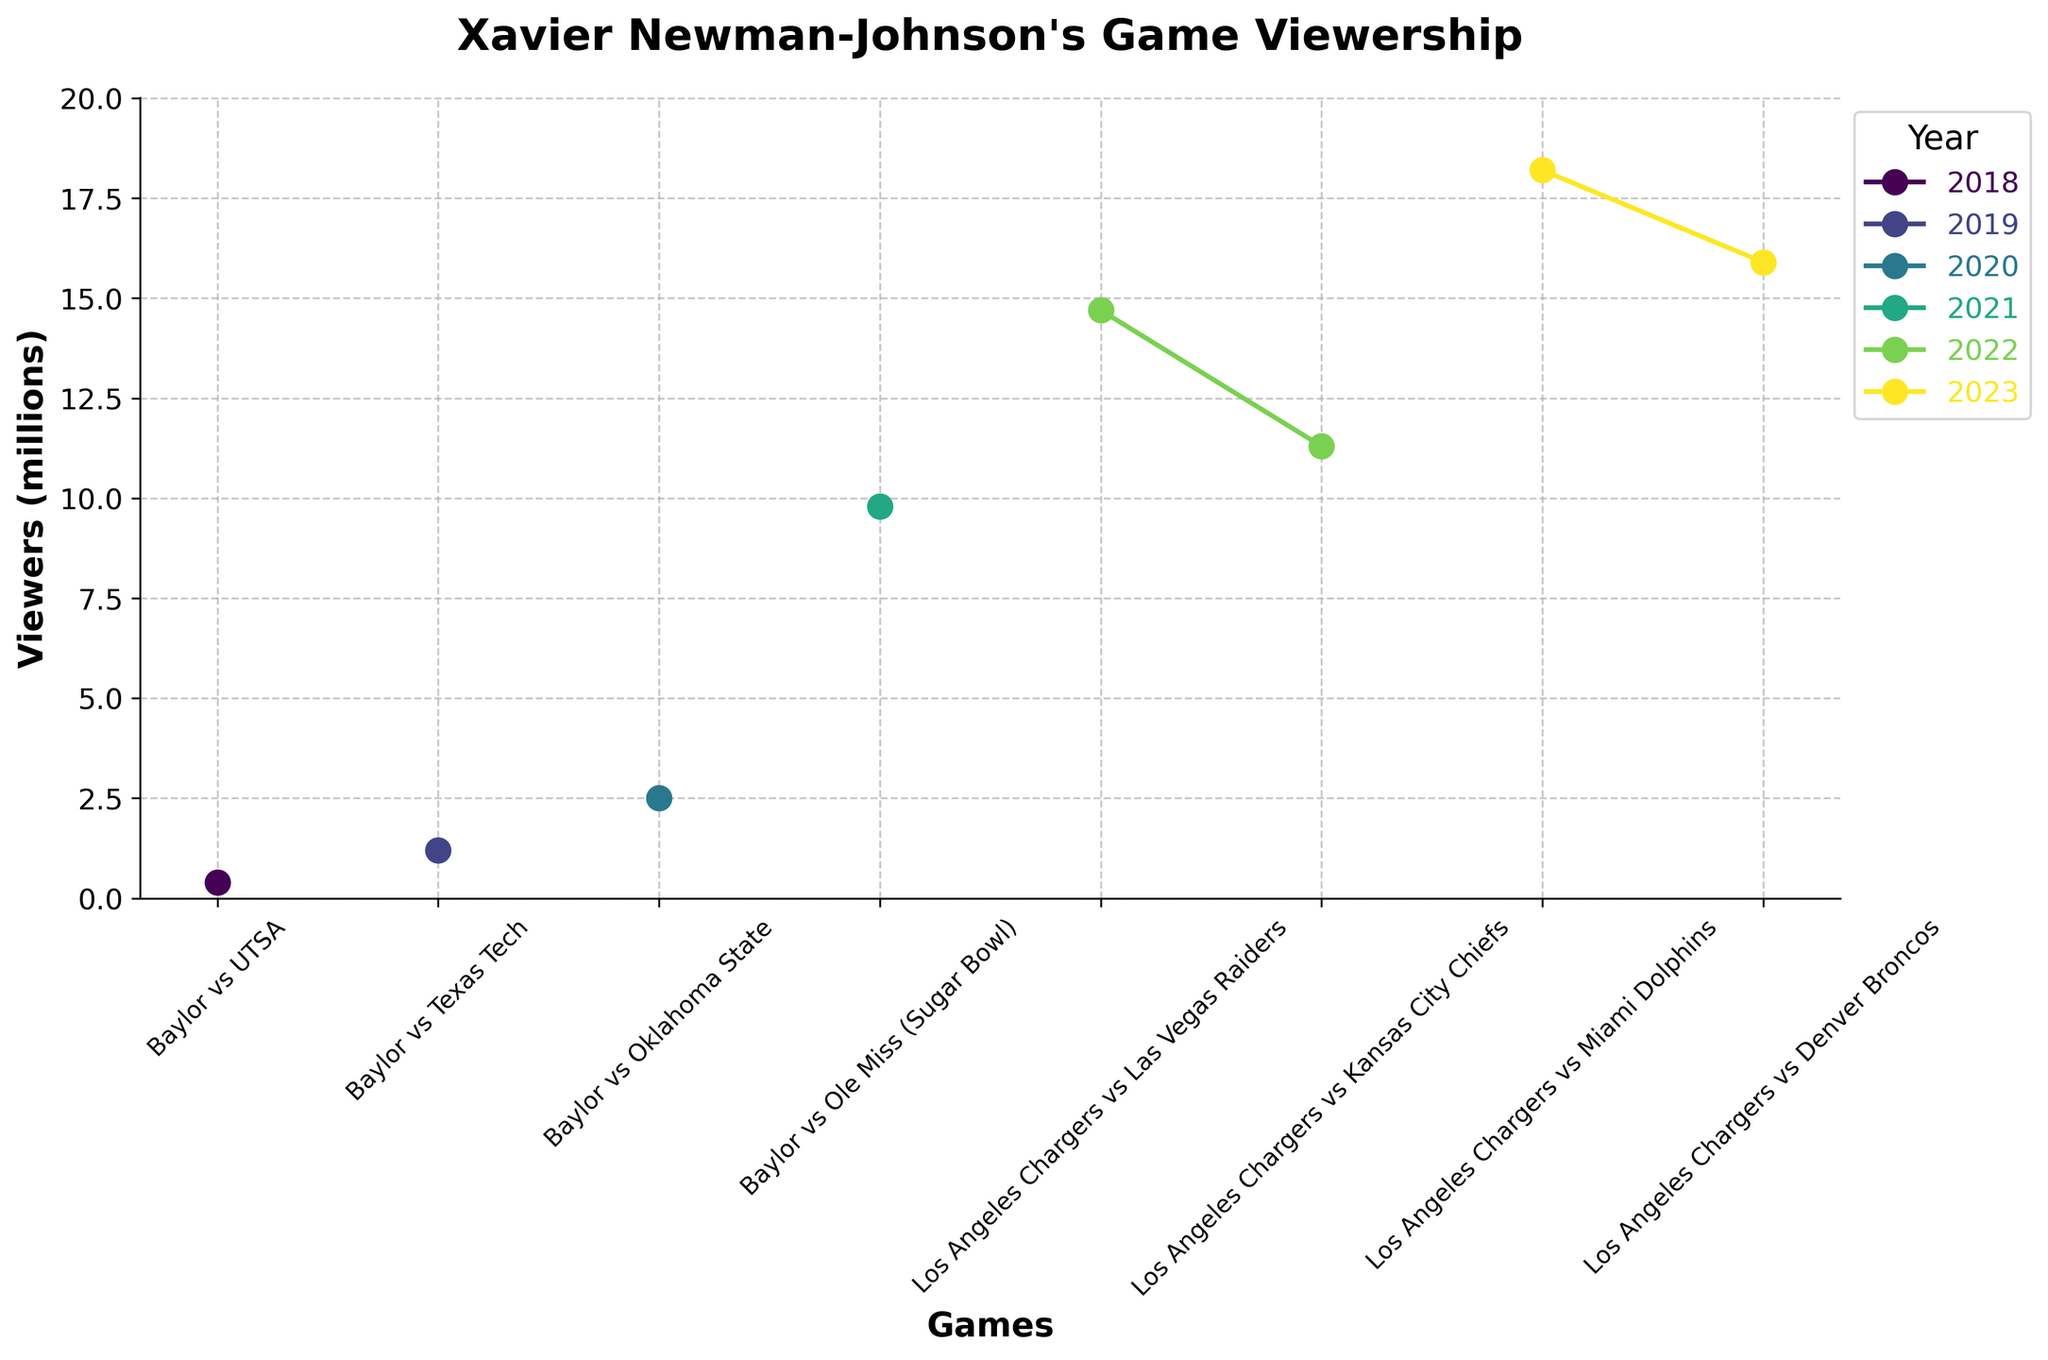What's the average number of viewers for the games in 2022? In 2022, the viewers for the games are 14.7 million and 11.3 million. Sum these two numbers to get 26 million, and then divide by 2 to get the average. 26 / 2 = 13
Answer: 13 Which game had the highest viewership and in which year did it occur? The highest bar in the chart represents the Los Angeles Chargers vs Miami Dolphins game with 18.2 million viewers in 2023.
Answer: Los Angeles Chargers vs Miami Dolphins, 2023 How did viewership change from the 2021 Sugar Bowl to the Los Angeles Chargers vs Raiders game in 2022? The viewership in the 2021 Sugar Bowl was 9.8 million. For the Los Angeles Chargers vs Raiders game in 2022, it was 14.7 million. Subtract 9.8 from 14.7 to see the increase. 14.7 - 9.8 = 4.9 million increase.
Answer: 4.9 million increase What's the total viewership for games in 2023? The viewers for the 2023 games are 18.2 million and 15.9 million. Sum these two numbers to get the total. 18.2 + 15.9 = 34.1 million.
Answer: 34.1 million Which game had the lowest viewership, and what was the network broadcasting it? The lowest bar in the chart represents the Baylor vs UTSA game with 0.4 million viewers, broadcasted on Fox Sports Southwest.
Answer: Baylor vs UTSA, Fox Sports Southwest Is there a trend in viewership from college to professional games? The viewership generally increases from college games (e.g., 0.4 million to 2.5 million) to professional games (e.g., up to 18.2 million). The trend shows rising popularity.
Answer: Increasing trend Which year saw the highest increase in viewership compared to the previous year? Calculate the changes in viewership year by year: From 2018 to 2019, it went from 0.4 to 1.2 million (0.8 increase). From 2019 to 2020, it went from 1.2 to 2.5 million (1.3 increase). From 2020 to 2021, it went from 2.5 to 9.8 million (7.3 increase). From 2021 to 2022, it went from 9.8 to 14.7 million (4.9 increase). From 2022 to 2023, it went from 14.7 to 18.2 million (3.5 increase). The highest increase was from 2020 to 2021.
Answer: 2020 to 2021 